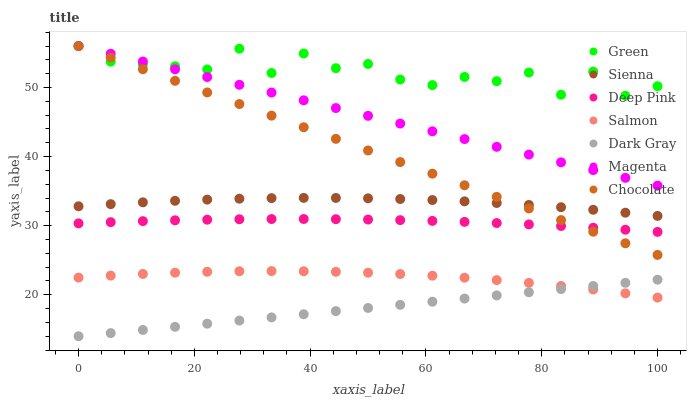Does Dark Gray have the minimum area under the curve?
Answer yes or no. Yes. Does Green have the maximum area under the curve?
Answer yes or no. Yes. Does Deep Pink have the minimum area under the curve?
Answer yes or no. No. Does Deep Pink have the maximum area under the curve?
Answer yes or no. No. Is Dark Gray the smoothest?
Answer yes or no. Yes. Is Green the roughest?
Answer yes or no. Yes. Is Deep Pink the smoothest?
Answer yes or no. No. Is Deep Pink the roughest?
Answer yes or no. No. Does Dark Gray have the lowest value?
Answer yes or no. Yes. Does Deep Pink have the lowest value?
Answer yes or no. No. Does Magenta have the highest value?
Answer yes or no. Yes. Does Deep Pink have the highest value?
Answer yes or no. No. Is Salmon less than Sienna?
Answer yes or no. Yes. Is Sienna greater than Deep Pink?
Answer yes or no. Yes. Does Salmon intersect Dark Gray?
Answer yes or no. Yes. Is Salmon less than Dark Gray?
Answer yes or no. No. Is Salmon greater than Dark Gray?
Answer yes or no. No. Does Salmon intersect Sienna?
Answer yes or no. No. 